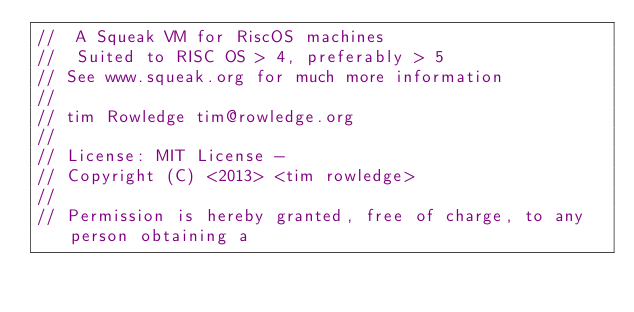Convert code to text. <code><loc_0><loc_0><loc_500><loc_500><_C_>//  A Squeak VM for RiscOS machines
//  Suited to RISC OS > 4, preferably > 5
// See www.squeak.org for much more information
//
// tim Rowledge tim@rowledge.org
//
// License: MIT License -
// Copyright (C) <2013> <tim rowledge>
//
// Permission is hereby granted, free of charge, to any person obtaining a</code> 